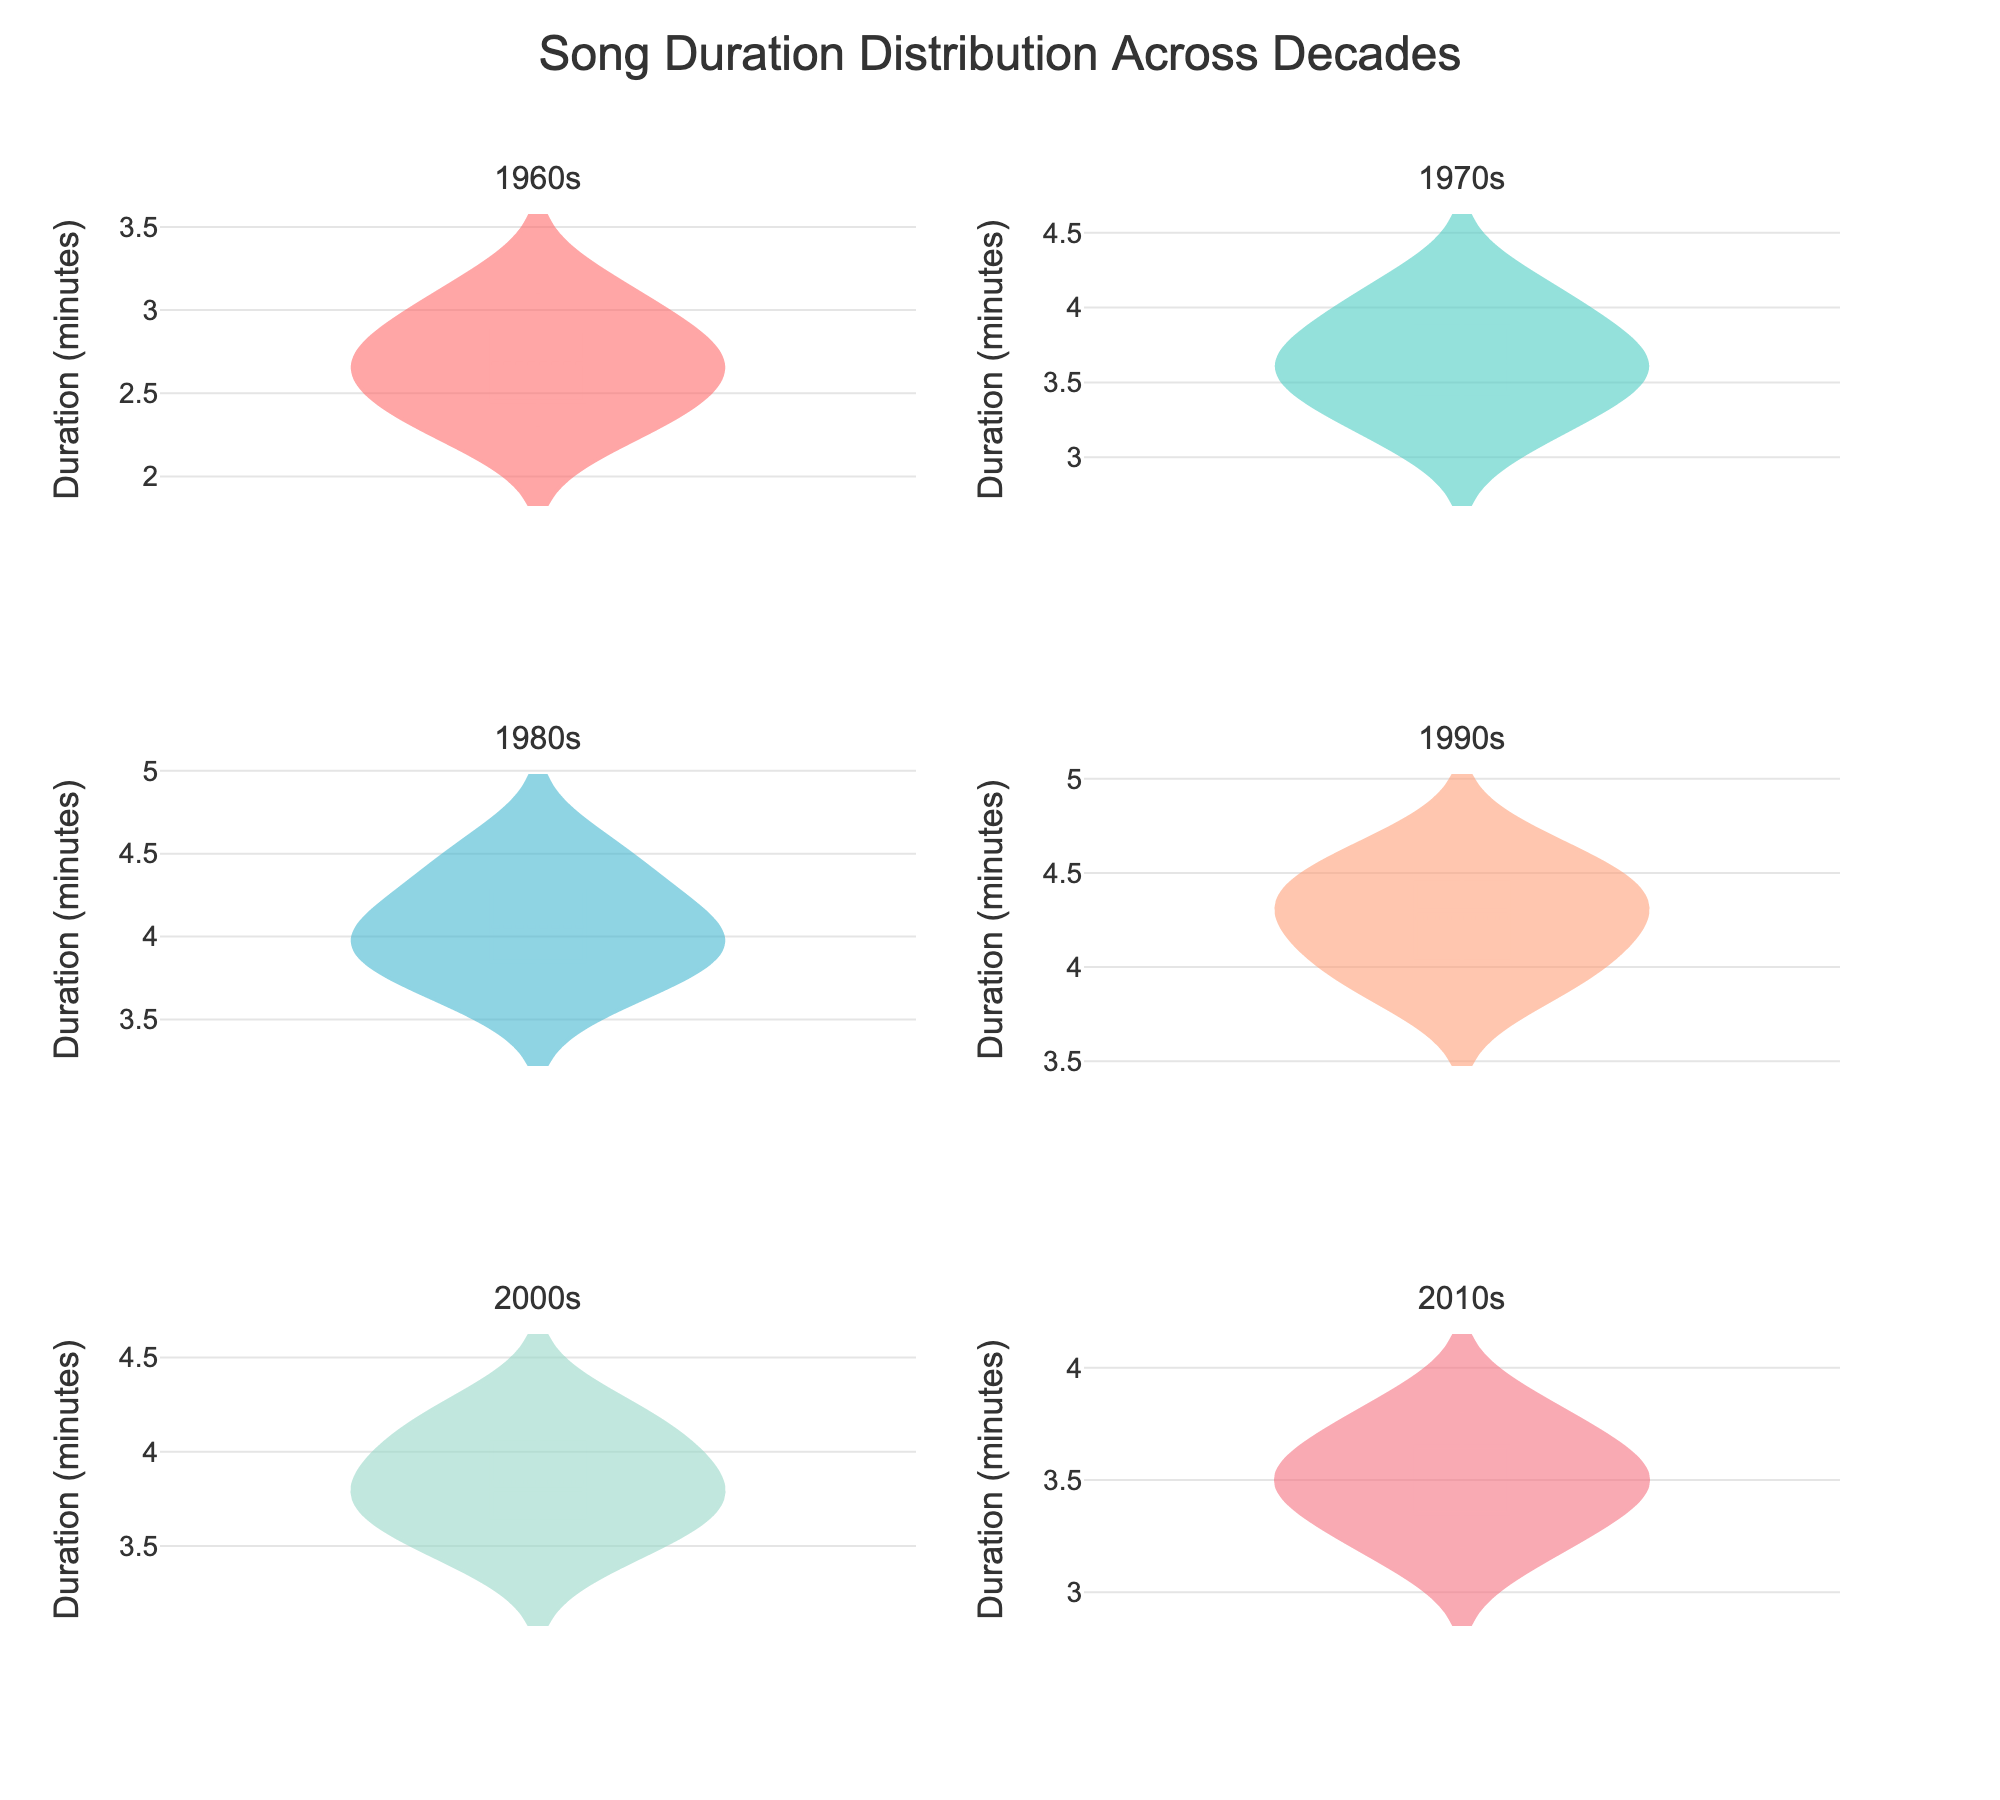What is the title of the plot? The title is located at the top of the plot. In this case, it should read "Song Duration Distribution Across Decades," which is clearly visible in the figure.
Answer: Song Duration Distribution Across Decades How is the duration of songs distributed in the 1960s compared to the 2000s? Look at the violin plots for the 1960s and 2000s subplots. Note the spread, central tendencies, and ranges of the duration distributions for each decade. You'll observe that 1960s songs tend to be shorter in duration compared to 2000s songs, which show a slightly higher duration on average.
Answer: 1960s songs are shorter Which decade has the widest spread in song durations? By visually comparing the widths of all the violin plots, you can identify which decade has the longest duration between the shortest and longest songs. The 1980s and 1990s appear to have the widest spread.
Answer: 1980s and 1990s What is the mean duration for songs in the 1990s? The mean duration is indicated by the line in the middle of the violin plot for the 1990s subplot. By observing this line, you can determine that the mean song duration is approximately 4.3 minutes.
Answer: 4.3 minutes Which decade shows the shortest average song duration? Check the mean lines across all violin plots. The mean duration in the 1960s subplot appears to be the shortest compared to other decades.
Answer: 1960s Is there a noticeable trend in song durations from the 1960s to the 2010s? By observing the trends across all subplot distributions, you can identify whether song durations have increased, decreased, or remained stable. There's a slight upward trend in song durations from the 1960s to the 1990s, with some variation in the 2000s and 2010s.
Answer: Slight upward trend What is the range of song durations in the 2000s? Range is the difference between the maximum and minimum durations observed in the violin plot for the 2000s. The maximum is around 4.2 minutes, and the minimum is around 3.5 minutes. Thus, the range is approximately 0.7 minutes.
Answer: 0.7 minutes Do the song durations in the 2010s vary more or less than the 1970s? Compare the width of the violin plots for both decades. The 2010s have a narrower distribution compared to the 1970s, indicating less variation in song durations.
Answer: Less Which decade seems to be an outlier in terms of the consistency of song durations? An outlier will show a markedly different pattern. The 1960s have a notably tighter clustering of song durations, making them an outlier in terms of consistency compared to other decades, which have broader distributions.
Answer: 1960s 